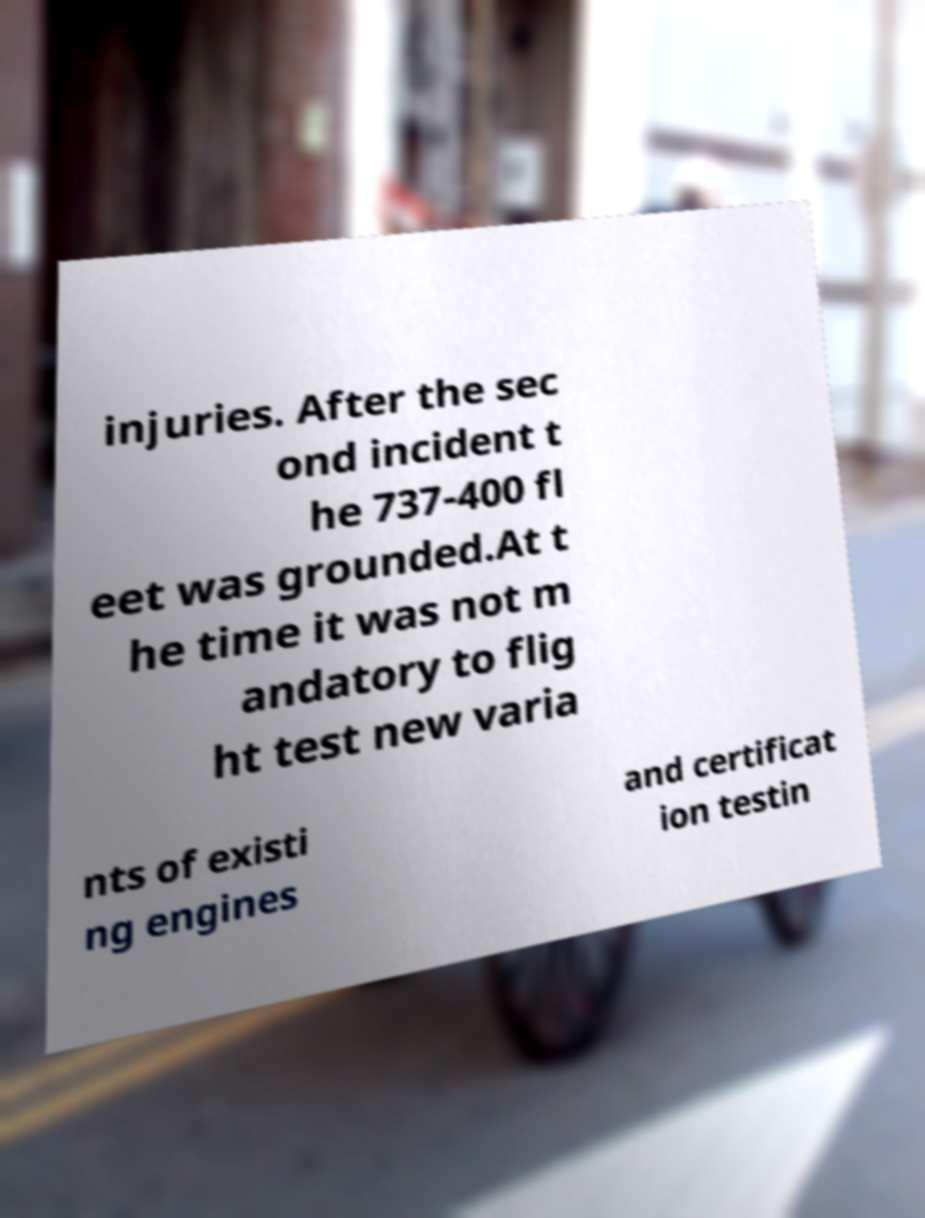Can you read and provide the text displayed in the image?This photo seems to have some interesting text. Can you extract and type it out for me? injuries. After the sec ond incident t he 737-400 fl eet was grounded.At t he time it was not m andatory to flig ht test new varia nts of existi ng engines and certificat ion testin 